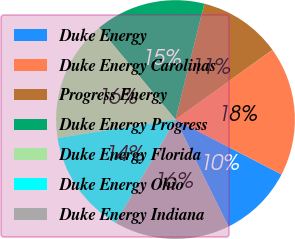<chart> <loc_0><loc_0><loc_500><loc_500><pie_chart><fcel>Duke Energy<fcel>Duke Energy Carolinas<fcel>Progress Energy<fcel>Duke Energy Progress<fcel>Duke Energy Florida<fcel>Duke Energy Ohio<fcel>Duke Energy Indiana<nl><fcel>10.07%<fcel>17.54%<fcel>11.19%<fcel>14.93%<fcel>16.42%<fcel>14.18%<fcel>15.67%<nl></chart> 